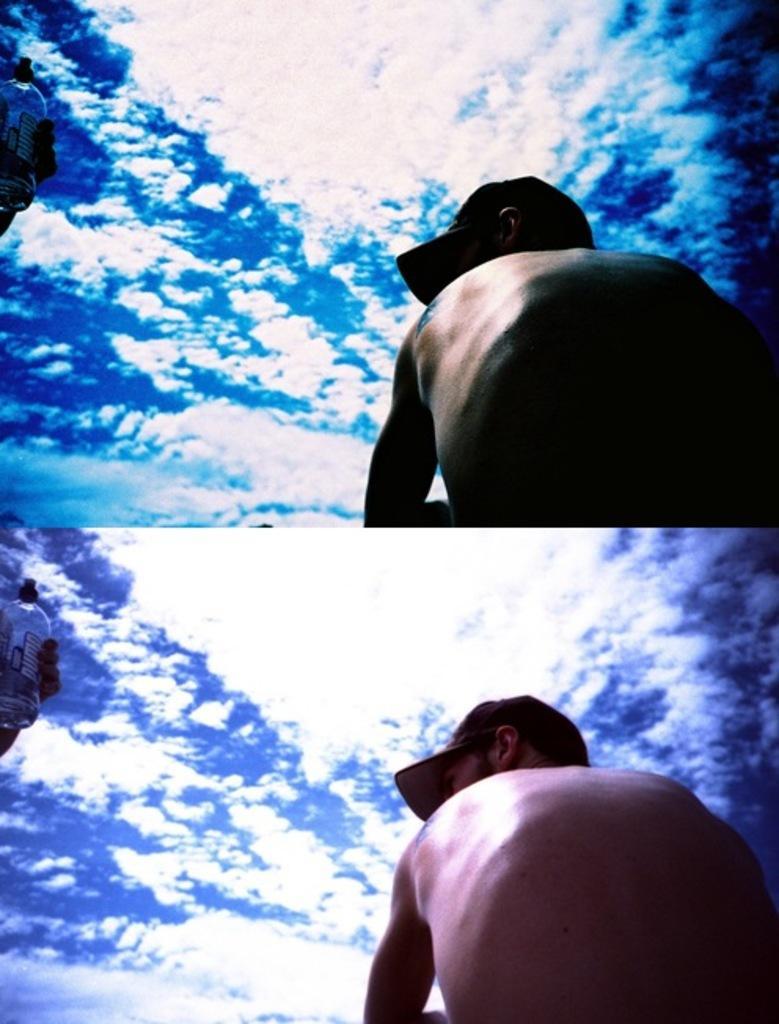Could you give a brief overview of what you see in this image? This is a collage image. In this image I can see the person with the cap. To the left there is an another person holding the bottle. In the background I can see the clouds and the sky. 